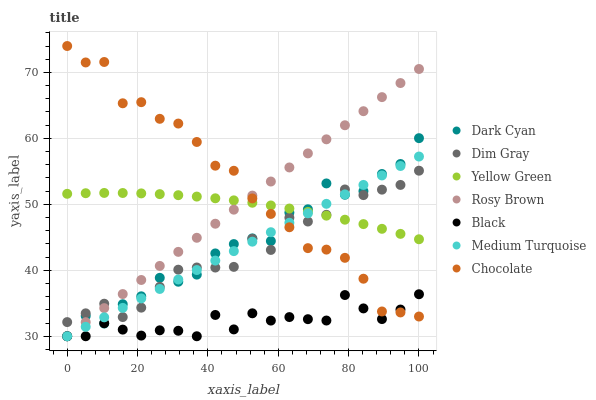Does Black have the minimum area under the curve?
Answer yes or no. Yes. Does Chocolate have the maximum area under the curve?
Answer yes or no. Yes. Does Yellow Green have the minimum area under the curve?
Answer yes or no. No. Does Yellow Green have the maximum area under the curve?
Answer yes or no. No. Is Rosy Brown the smoothest?
Answer yes or no. Yes. Is Dark Cyan the roughest?
Answer yes or no. Yes. Is Yellow Green the smoothest?
Answer yes or no. No. Is Yellow Green the roughest?
Answer yes or no. No. Does Rosy Brown have the lowest value?
Answer yes or no. Yes. Does Yellow Green have the lowest value?
Answer yes or no. No. Does Chocolate have the highest value?
Answer yes or no. Yes. Does Yellow Green have the highest value?
Answer yes or no. No. Is Black less than Yellow Green?
Answer yes or no. Yes. Is Yellow Green greater than Black?
Answer yes or no. Yes. Does Black intersect Chocolate?
Answer yes or no. Yes. Is Black less than Chocolate?
Answer yes or no. No. Is Black greater than Chocolate?
Answer yes or no. No. Does Black intersect Yellow Green?
Answer yes or no. No. 